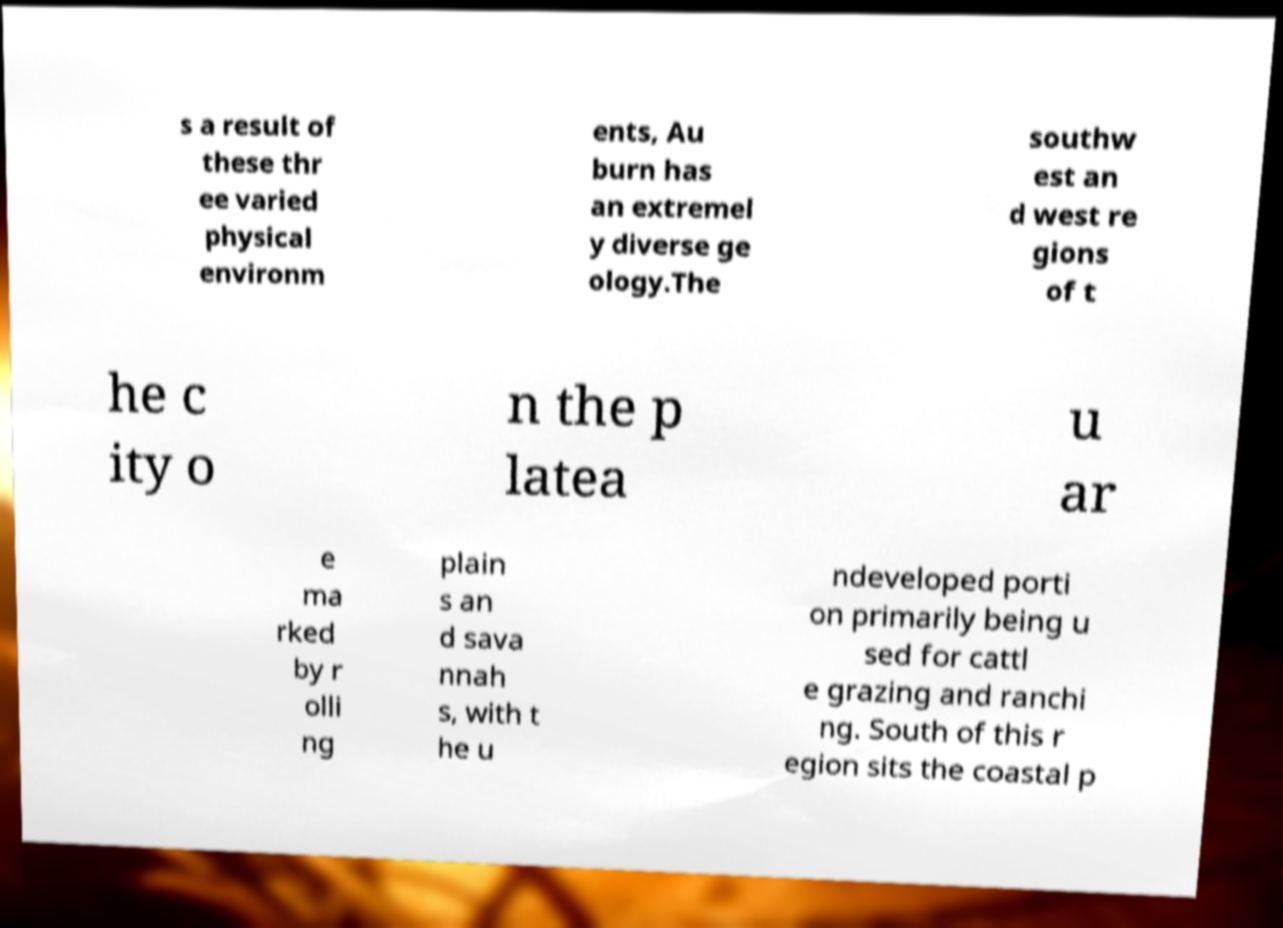What messages or text are displayed in this image? I need them in a readable, typed format. s a result of these thr ee varied physical environm ents, Au burn has an extremel y diverse ge ology.The southw est an d west re gions of t he c ity o n the p latea u ar e ma rked by r olli ng plain s an d sava nnah s, with t he u ndeveloped porti on primarily being u sed for cattl e grazing and ranchi ng. South of this r egion sits the coastal p 